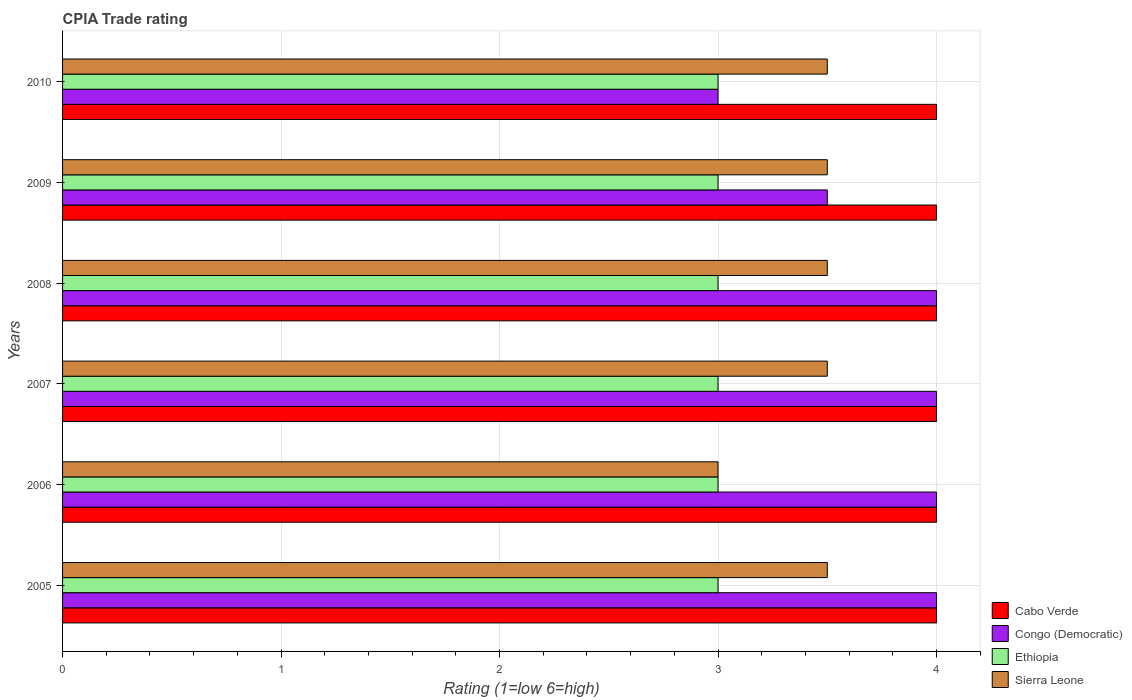How many different coloured bars are there?
Ensure brevity in your answer.  4. Are the number of bars per tick equal to the number of legend labels?
Ensure brevity in your answer.  Yes. Are the number of bars on each tick of the Y-axis equal?
Keep it short and to the point. Yes. How many bars are there on the 6th tick from the top?
Your answer should be very brief. 4. Across all years, what is the maximum CPIA rating in Congo (Democratic)?
Your response must be concise. 4. Across all years, what is the minimum CPIA rating in Sierra Leone?
Keep it short and to the point. 3. In which year was the CPIA rating in Ethiopia minimum?
Offer a very short reply. 2005. What is the total CPIA rating in Congo (Democratic) in the graph?
Provide a short and direct response. 22.5. What is the difference between the CPIA rating in Cabo Verde in 2006 and that in 2009?
Your answer should be compact. 0. What is the difference between the CPIA rating in Congo (Democratic) in 2005 and the CPIA rating in Sierra Leone in 2007?
Provide a short and direct response. 0.5. What is the average CPIA rating in Congo (Democratic) per year?
Your answer should be very brief. 3.75. In the year 2010, what is the difference between the CPIA rating in Sierra Leone and CPIA rating in Congo (Democratic)?
Make the answer very short. 0.5. In how many years, is the CPIA rating in Cabo Verde greater than 2.2 ?
Give a very brief answer. 6. Is the CPIA rating in Ethiopia in 2008 less than that in 2009?
Offer a very short reply. No. What is the difference between the highest and the second highest CPIA rating in Ethiopia?
Provide a short and direct response. 0. What is the difference between the highest and the lowest CPIA rating in Ethiopia?
Make the answer very short. 0. Is the sum of the CPIA rating in Ethiopia in 2007 and 2009 greater than the maximum CPIA rating in Sierra Leone across all years?
Keep it short and to the point. Yes. What does the 1st bar from the top in 2007 represents?
Keep it short and to the point. Sierra Leone. What does the 3rd bar from the bottom in 2007 represents?
Provide a short and direct response. Ethiopia. Is it the case that in every year, the sum of the CPIA rating in Ethiopia and CPIA rating in Cabo Verde is greater than the CPIA rating in Congo (Democratic)?
Provide a succinct answer. Yes. Are all the bars in the graph horizontal?
Make the answer very short. Yes. How many years are there in the graph?
Give a very brief answer. 6. What is the difference between two consecutive major ticks on the X-axis?
Your answer should be compact. 1. Does the graph contain any zero values?
Your response must be concise. No. How many legend labels are there?
Provide a short and direct response. 4. What is the title of the graph?
Your answer should be compact. CPIA Trade rating. Does "Congo (Republic)" appear as one of the legend labels in the graph?
Ensure brevity in your answer.  No. What is the label or title of the X-axis?
Give a very brief answer. Rating (1=low 6=high). What is the label or title of the Y-axis?
Provide a succinct answer. Years. What is the Rating (1=low 6=high) of Congo (Democratic) in 2005?
Your response must be concise. 4. What is the Rating (1=low 6=high) in Ethiopia in 2005?
Your answer should be compact. 3. What is the Rating (1=low 6=high) in Congo (Democratic) in 2006?
Provide a succinct answer. 4. What is the Rating (1=low 6=high) of Ethiopia in 2006?
Offer a very short reply. 3. What is the Rating (1=low 6=high) in Ethiopia in 2007?
Keep it short and to the point. 3. What is the Rating (1=low 6=high) in Cabo Verde in 2008?
Keep it short and to the point. 4. What is the Rating (1=low 6=high) in Congo (Democratic) in 2008?
Offer a very short reply. 4. What is the Rating (1=low 6=high) in Ethiopia in 2009?
Make the answer very short. 3. What is the Rating (1=low 6=high) of Sierra Leone in 2009?
Provide a succinct answer. 3.5. What is the Rating (1=low 6=high) of Ethiopia in 2010?
Keep it short and to the point. 3. What is the Rating (1=low 6=high) in Sierra Leone in 2010?
Make the answer very short. 3.5. Across all years, what is the maximum Rating (1=low 6=high) of Congo (Democratic)?
Your answer should be compact. 4. Across all years, what is the minimum Rating (1=low 6=high) of Ethiopia?
Ensure brevity in your answer.  3. What is the total Rating (1=low 6=high) of Cabo Verde in the graph?
Offer a terse response. 24. What is the total Rating (1=low 6=high) of Congo (Democratic) in the graph?
Offer a very short reply. 22.5. What is the difference between the Rating (1=low 6=high) of Sierra Leone in 2005 and that in 2006?
Offer a terse response. 0.5. What is the difference between the Rating (1=low 6=high) in Sierra Leone in 2005 and that in 2007?
Offer a very short reply. 0. What is the difference between the Rating (1=low 6=high) in Cabo Verde in 2005 and that in 2009?
Make the answer very short. 0. What is the difference between the Rating (1=low 6=high) of Congo (Democratic) in 2005 and that in 2009?
Offer a very short reply. 0.5. What is the difference between the Rating (1=low 6=high) in Ethiopia in 2005 and that in 2009?
Provide a succinct answer. 0. What is the difference between the Rating (1=low 6=high) of Sierra Leone in 2005 and that in 2009?
Keep it short and to the point. 0. What is the difference between the Rating (1=low 6=high) of Congo (Democratic) in 2005 and that in 2010?
Your answer should be compact. 1. What is the difference between the Rating (1=low 6=high) of Ethiopia in 2006 and that in 2007?
Keep it short and to the point. 0. What is the difference between the Rating (1=low 6=high) in Sierra Leone in 2006 and that in 2007?
Your answer should be very brief. -0.5. What is the difference between the Rating (1=low 6=high) in Cabo Verde in 2006 and that in 2008?
Ensure brevity in your answer.  0. What is the difference between the Rating (1=low 6=high) in Congo (Democratic) in 2006 and that in 2009?
Provide a succinct answer. 0.5. What is the difference between the Rating (1=low 6=high) of Sierra Leone in 2006 and that in 2009?
Your answer should be compact. -0.5. What is the difference between the Rating (1=low 6=high) of Cabo Verde in 2006 and that in 2010?
Ensure brevity in your answer.  0. What is the difference between the Rating (1=low 6=high) in Congo (Democratic) in 2006 and that in 2010?
Keep it short and to the point. 1. What is the difference between the Rating (1=low 6=high) of Cabo Verde in 2007 and that in 2008?
Give a very brief answer. 0. What is the difference between the Rating (1=low 6=high) of Congo (Democratic) in 2007 and that in 2008?
Provide a succinct answer. 0. What is the difference between the Rating (1=low 6=high) of Cabo Verde in 2007 and that in 2009?
Provide a short and direct response. 0. What is the difference between the Rating (1=low 6=high) in Congo (Democratic) in 2007 and that in 2009?
Make the answer very short. 0.5. What is the difference between the Rating (1=low 6=high) of Ethiopia in 2007 and that in 2009?
Make the answer very short. 0. What is the difference between the Rating (1=low 6=high) of Sierra Leone in 2007 and that in 2009?
Give a very brief answer. 0. What is the difference between the Rating (1=low 6=high) in Sierra Leone in 2007 and that in 2010?
Keep it short and to the point. 0. What is the difference between the Rating (1=low 6=high) in Congo (Democratic) in 2008 and that in 2009?
Offer a very short reply. 0.5. What is the difference between the Rating (1=low 6=high) in Ethiopia in 2008 and that in 2009?
Your response must be concise. 0. What is the difference between the Rating (1=low 6=high) in Cabo Verde in 2008 and that in 2010?
Make the answer very short. 0. What is the difference between the Rating (1=low 6=high) of Sierra Leone in 2008 and that in 2010?
Provide a succinct answer. 0. What is the difference between the Rating (1=low 6=high) of Cabo Verde in 2009 and that in 2010?
Your answer should be compact. 0. What is the difference between the Rating (1=low 6=high) of Congo (Democratic) in 2009 and that in 2010?
Your answer should be very brief. 0.5. What is the difference between the Rating (1=low 6=high) in Ethiopia in 2009 and that in 2010?
Provide a succinct answer. 0. What is the difference between the Rating (1=low 6=high) of Cabo Verde in 2005 and the Rating (1=low 6=high) of Congo (Democratic) in 2006?
Your answer should be very brief. 0. What is the difference between the Rating (1=low 6=high) in Cabo Verde in 2005 and the Rating (1=low 6=high) in Sierra Leone in 2006?
Provide a succinct answer. 1. What is the difference between the Rating (1=low 6=high) of Cabo Verde in 2005 and the Rating (1=low 6=high) of Congo (Democratic) in 2007?
Make the answer very short. 0. What is the difference between the Rating (1=low 6=high) in Cabo Verde in 2005 and the Rating (1=low 6=high) in Ethiopia in 2007?
Ensure brevity in your answer.  1. What is the difference between the Rating (1=low 6=high) in Cabo Verde in 2005 and the Rating (1=low 6=high) in Congo (Democratic) in 2008?
Offer a terse response. 0. What is the difference between the Rating (1=low 6=high) of Congo (Democratic) in 2005 and the Rating (1=low 6=high) of Ethiopia in 2008?
Your response must be concise. 1. What is the difference between the Rating (1=low 6=high) in Congo (Democratic) in 2005 and the Rating (1=low 6=high) in Ethiopia in 2009?
Keep it short and to the point. 1. What is the difference between the Rating (1=low 6=high) in Congo (Democratic) in 2005 and the Rating (1=low 6=high) in Sierra Leone in 2009?
Ensure brevity in your answer.  0.5. What is the difference between the Rating (1=low 6=high) of Cabo Verde in 2005 and the Rating (1=low 6=high) of Congo (Democratic) in 2010?
Your response must be concise. 1. What is the difference between the Rating (1=low 6=high) of Congo (Democratic) in 2005 and the Rating (1=low 6=high) of Sierra Leone in 2010?
Your response must be concise. 0.5. What is the difference between the Rating (1=low 6=high) of Cabo Verde in 2006 and the Rating (1=low 6=high) of Ethiopia in 2007?
Your answer should be very brief. 1. What is the difference between the Rating (1=low 6=high) of Ethiopia in 2006 and the Rating (1=low 6=high) of Sierra Leone in 2007?
Provide a succinct answer. -0.5. What is the difference between the Rating (1=low 6=high) in Cabo Verde in 2006 and the Rating (1=low 6=high) in Congo (Democratic) in 2008?
Keep it short and to the point. 0. What is the difference between the Rating (1=low 6=high) in Cabo Verde in 2006 and the Rating (1=low 6=high) in Ethiopia in 2008?
Your answer should be compact. 1. What is the difference between the Rating (1=low 6=high) in Congo (Democratic) in 2006 and the Rating (1=low 6=high) in Sierra Leone in 2008?
Ensure brevity in your answer.  0.5. What is the difference between the Rating (1=low 6=high) in Cabo Verde in 2006 and the Rating (1=low 6=high) in Congo (Democratic) in 2009?
Ensure brevity in your answer.  0.5. What is the difference between the Rating (1=low 6=high) in Cabo Verde in 2006 and the Rating (1=low 6=high) in Sierra Leone in 2009?
Your response must be concise. 0.5. What is the difference between the Rating (1=low 6=high) in Ethiopia in 2006 and the Rating (1=low 6=high) in Sierra Leone in 2010?
Keep it short and to the point. -0.5. What is the difference between the Rating (1=low 6=high) of Congo (Democratic) in 2007 and the Rating (1=low 6=high) of Ethiopia in 2008?
Keep it short and to the point. 1. What is the difference between the Rating (1=low 6=high) in Congo (Democratic) in 2007 and the Rating (1=low 6=high) in Sierra Leone in 2008?
Provide a short and direct response. 0.5. What is the difference between the Rating (1=low 6=high) in Ethiopia in 2007 and the Rating (1=low 6=high) in Sierra Leone in 2008?
Offer a terse response. -0.5. What is the difference between the Rating (1=low 6=high) in Congo (Democratic) in 2007 and the Rating (1=low 6=high) in Ethiopia in 2009?
Your answer should be very brief. 1. What is the difference between the Rating (1=low 6=high) in Congo (Democratic) in 2007 and the Rating (1=low 6=high) in Sierra Leone in 2009?
Keep it short and to the point. 0.5. What is the difference between the Rating (1=low 6=high) of Cabo Verde in 2007 and the Rating (1=low 6=high) of Ethiopia in 2010?
Your response must be concise. 1. What is the difference between the Rating (1=low 6=high) of Cabo Verde in 2007 and the Rating (1=low 6=high) of Sierra Leone in 2010?
Provide a short and direct response. 0.5. What is the difference between the Rating (1=low 6=high) of Congo (Democratic) in 2007 and the Rating (1=low 6=high) of Ethiopia in 2010?
Your response must be concise. 1. What is the difference between the Rating (1=low 6=high) of Cabo Verde in 2008 and the Rating (1=low 6=high) of Ethiopia in 2009?
Ensure brevity in your answer.  1. What is the difference between the Rating (1=low 6=high) in Cabo Verde in 2008 and the Rating (1=low 6=high) in Sierra Leone in 2009?
Your answer should be compact. 0.5. What is the difference between the Rating (1=low 6=high) in Congo (Democratic) in 2008 and the Rating (1=low 6=high) in Ethiopia in 2009?
Make the answer very short. 1. What is the difference between the Rating (1=low 6=high) in Cabo Verde in 2008 and the Rating (1=low 6=high) in Congo (Democratic) in 2010?
Your answer should be compact. 1. What is the difference between the Rating (1=low 6=high) in Cabo Verde in 2008 and the Rating (1=low 6=high) in Ethiopia in 2010?
Ensure brevity in your answer.  1. What is the difference between the Rating (1=low 6=high) of Cabo Verde in 2008 and the Rating (1=low 6=high) of Sierra Leone in 2010?
Offer a very short reply. 0.5. What is the difference between the Rating (1=low 6=high) of Congo (Democratic) in 2008 and the Rating (1=low 6=high) of Ethiopia in 2010?
Give a very brief answer. 1. What is the difference between the Rating (1=low 6=high) of Ethiopia in 2008 and the Rating (1=low 6=high) of Sierra Leone in 2010?
Your response must be concise. -0.5. What is the difference between the Rating (1=low 6=high) in Cabo Verde in 2009 and the Rating (1=low 6=high) in Congo (Democratic) in 2010?
Offer a terse response. 1. What is the difference between the Rating (1=low 6=high) in Cabo Verde in 2009 and the Rating (1=low 6=high) in Ethiopia in 2010?
Provide a short and direct response. 1. What is the difference between the Rating (1=low 6=high) of Cabo Verde in 2009 and the Rating (1=low 6=high) of Sierra Leone in 2010?
Keep it short and to the point. 0.5. What is the difference between the Rating (1=low 6=high) of Congo (Democratic) in 2009 and the Rating (1=low 6=high) of Sierra Leone in 2010?
Offer a very short reply. 0. What is the average Rating (1=low 6=high) in Congo (Democratic) per year?
Provide a short and direct response. 3.75. What is the average Rating (1=low 6=high) of Ethiopia per year?
Ensure brevity in your answer.  3. What is the average Rating (1=low 6=high) in Sierra Leone per year?
Your answer should be compact. 3.42. In the year 2005, what is the difference between the Rating (1=low 6=high) of Cabo Verde and Rating (1=low 6=high) of Congo (Democratic)?
Give a very brief answer. 0. In the year 2005, what is the difference between the Rating (1=low 6=high) of Cabo Verde and Rating (1=low 6=high) of Ethiopia?
Ensure brevity in your answer.  1. In the year 2005, what is the difference between the Rating (1=low 6=high) in Cabo Verde and Rating (1=low 6=high) in Sierra Leone?
Offer a very short reply. 0.5. In the year 2005, what is the difference between the Rating (1=low 6=high) of Congo (Democratic) and Rating (1=low 6=high) of Ethiopia?
Give a very brief answer. 1. In the year 2006, what is the difference between the Rating (1=low 6=high) of Cabo Verde and Rating (1=low 6=high) of Congo (Democratic)?
Offer a terse response. 0. In the year 2006, what is the difference between the Rating (1=low 6=high) in Congo (Democratic) and Rating (1=low 6=high) in Ethiopia?
Make the answer very short. 1. In the year 2006, what is the difference between the Rating (1=low 6=high) of Congo (Democratic) and Rating (1=low 6=high) of Sierra Leone?
Your answer should be compact. 1. In the year 2007, what is the difference between the Rating (1=low 6=high) in Cabo Verde and Rating (1=low 6=high) in Ethiopia?
Give a very brief answer. 1. In the year 2007, what is the difference between the Rating (1=low 6=high) of Cabo Verde and Rating (1=low 6=high) of Sierra Leone?
Your answer should be compact. 0.5. In the year 2007, what is the difference between the Rating (1=low 6=high) in Congo (Democratic) and Rating (1=low 6=high) in Sierra Leone?
Offer a terse response. 0.5. In the year 2007, what is the difference between the Rating (1=low 6=high) of Ethiopia and Rating (1=low 6=high) of Sierra Leone?
Offer a very short reply. -0.5. In the year 2008, what is the difference between the Rating (1=low 6=high) in Cabo Verde and Rating (1=low 6=high) in Ethiopia?
Your answer should be compact. 1. In the year 2008, what is the difference between the Rating (1=low 6=high) of Cabo Verde and Rating (1=low 6=high) of Sierra Leone?
Provide a succinct answer. 0.5. In the year 2008, what is the difference between the Rating (1=low 6=high) in Congo (Democratic) and Rating (1=low 6=high) in Ethiopia?
Provide a short and direct response. 1. In the year 2008, what is the difference between the Rating (1=low 6=high) of Congo (Democratic) and Rating (1=low 6=high) of Sierra Leone?
Offer a very short reply. 0.5. In the year 2009, what is the difference between the Rating (1=low 6=high) in Cabo Verde and Rating (1=low 6=high) in Congo (Democratic)?
Your response must be concise. 0.5. In the year 2009, what is the difference between the Rating (1=low 6=high) of Congo (Democratic) and Rating (1=low 6=high) of Ethiopia?
Your answer should be compact. 0.5. In the year 2009, what is the difference between the Rating (1=low 6=high) of Ethiopia and Rating (1=low 6=high) of Sierra Leone?
Give a very brief answer. -0.5. In the year 2010, what is the difference between the Rating (1=low 6=high) of Cabo Verde and Rating (1=low 6=high) of Ethiopia?
Ensure brevity in your answer.  1. What is the ratio of the Rating (1=low 6=high) in Congo (Democratic) in 2005 to that in 2006?
Offer a terse response. 1. What is the ratio of the Rating (1=low 6=high) of Sierra Leone in 2005 to that in 2006?
Provide a succinct answer. 1.17. What is the ratio of the Rating (1=low 6=high) of Cabo Verde in 2005 to that in 2007?
Your answer should be compact. 1. What is the ratio of the Rating (1=low 6=high) in Ethiopia in 2005 to that in 2007?
Provide a short and direct response. 1. What is the ratio of the Rating (1=low 6=high) of Sierra Leone in 2005 to that in 2007?
Offer a very short reply. 1. What is the ratio of the Rating (1=low 6=high) of Ethiopia in 2005 to that in 2008?
Give a very brief answer. 1. What is the ratio of the Rating (1=low 6=high) in Sierra Leone in 2005 to that in 2008?
Your answer should be very brief. 1. What is the ratio of the Rating (1=low 6=high) in Sierra Leone in 2005 to that in 2009?
Your answer should be very brief. 1. What is the ratio of the Rating (1=low 6=high) in Cabo Verde in 2005 to that in 2010?
Make the answer very short. 1. What is the ratio of the Rating (1=low 6=high) of Congo (Democratic) in 2005 to that in 2010?
Provide a succinct answer. 1.33. What is the ratio of the Rating (1=low 6=high) in Ethiopia in 2005 to that in 2010?
Provide a succinct answer. 1. What is the ratio of the Rating (1=low 6=high) in Sierra Leone in 2005 to that in 2010?
Offer a very short reply. 1. What is the ratio of the Rating (1=low 6=high) of Cabo Verde in 2006 to that in 2007?
Provide a succinct answer. 1. What is the ratio of the Rating (1=low 6=high) of Ethiopia in 2006 to that in 2007?
Keep it short and to the point. 1. What is the ratio of the Rating (1=low 6=high) in Sierra Leone in 2006 to that in 2007?
Provide a short and direct response. 0.86. What is the ratio of the Rating (1=low 6=high) in Congo (Democratic) in 2006 to that in 2008?
Provide a succinct answer. 1. What is the ratio of the Rating (1=low 6=high) of Cabo Verde in 2006 to that in 2010?
Give a very brief answer. 1. What is the ratio of the Rating (1=low 6=high) in Congo (Democratic) in 2006 to that in 2010?
Provide a succinct answer. 1.33. What is the ratio of the Rating (1=low 6=high) of Ethiopia in 2006 to that in 2010?
Your answer should be compact. 1. What is the ratio of the Rating (1=low 6=high) of Congo (Democratic) in 2007 to that in 2008?
Keep it short and to the point. 1. What is the ratio of the Rating (1=low 6=high) in Ethiopia in 2007 to that in 2008?
Your answer should be very brief. 1. What is the ratio of the Rating (1=low 6=high) in Sierra Leone in 2007 to that in 2008?
Your response must be concise. 1. What is the ratio of the Rating (1=low 6=high) in Ethiopia in 2007 to that in 2009?
Your response must be concise. 1. What is the ratio of the Rating (1=low 6=high) in Ethiopia in 2007 to that in 2010?
Make the answer very short. 1. What is the ratio of the Rating (1=low 6=high) of Cabo Verde in 2008 to that in 2009?
Give a very brief answer. 1. What is the ratio of the Rating (1=low 6=high) of Congo (Democratic) in 2008 to that in 2009?
Your answer should be very brief. 1.14. What is the ratio of the Rating (1=low 6=high) of Sierra Leone in 2008 to that in 2009?
Provide a short and direct response. 1. What is the ratio of the Rating (1=low 6=high) of Cabo Verde in 2008 to that in 2010?
Your answer should be very brief. 1. What is the ratio of the Rating (1=low 6=high) in Sierra Leone in 2008 to that in 2010?
Your answer should be very brief. 1. What is the ratio of the Rating (1=low 6=high) in Cabo Verde in 2009 to that in 2010?
Ensure brevity in your answer.  1. What is the ratio of the Rating (1=low 6=high) in Congo (Democratic) in 2009 to that in 2010?
Give a very brief answer. 1.17. What is the difference between the highest and the second highest Rating (1=low 6=high) in Cabo Verde?
Your response must be concise. 0. What is the difference between the highest and the lowest Rating (1=low 6=high) of Congo (Democratic)?
Provide a succinct answer. 1. What is the difference between the highest and the lowest Rating (1=low 6=high) in Sierra Leone?
Make the answer very short. 0.5. 